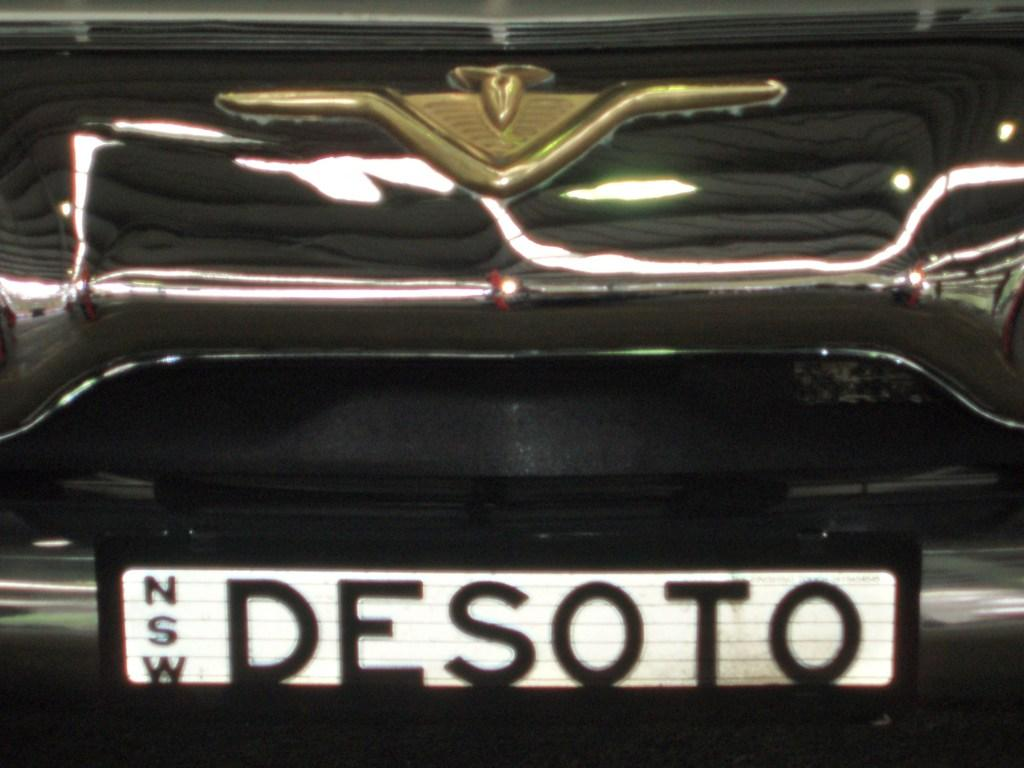<image>
Offer a succinct explanation of the picture presented. Just under the emblem of a black car is the word NSW DESOTO. 